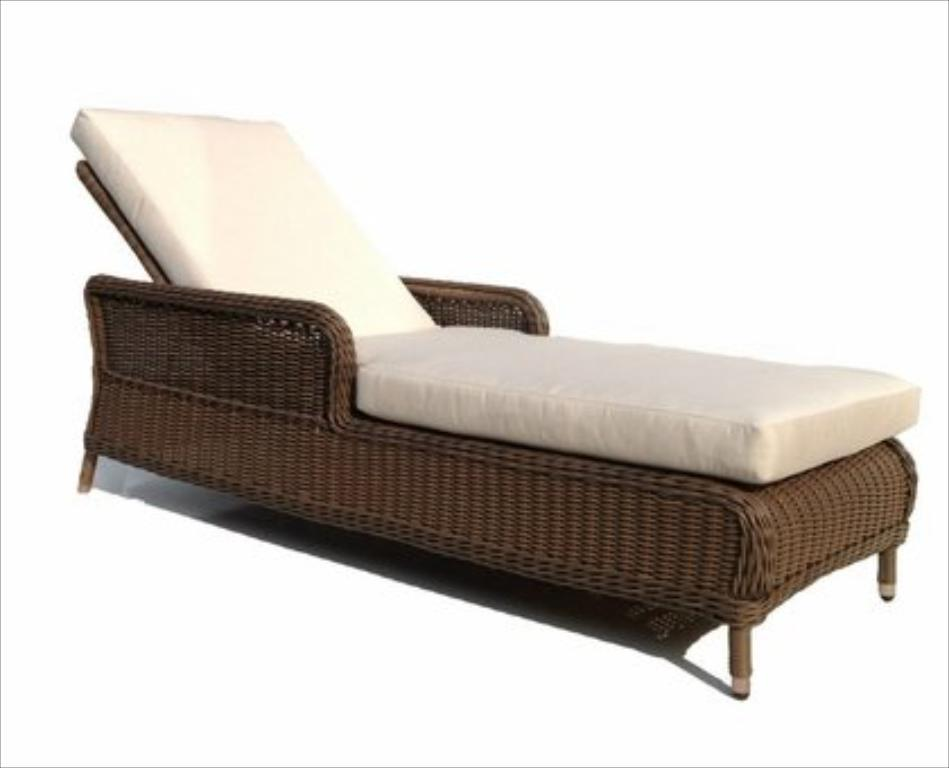What type of furniture is in the image that can be used as both a sofa and a bed? There is a sofa cum bed in the image. What other type of furniture is in the image? There is a wooden chair in the image. What is placed on the wooden chair? A white cushion is placed on the wooden chair. What question is being asked by the person sitting on the sofa cum bed in the image? There is no person sitting on the sofa cum bed in the image, and therefore no question is being asked. 